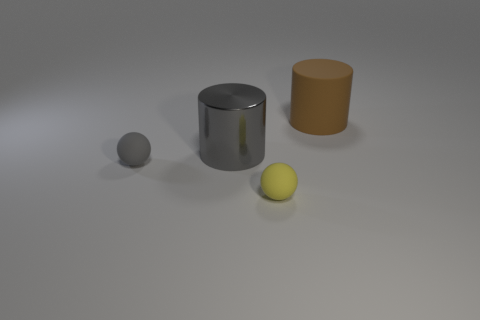What is the color of the other big shiny thing that is the same shape as the big brown thing?
Offer a terse response. Gray. What size is the other object that is the same shape as the tiny yellow rubber object?
Give a very brief answer. Small. What number of gray cylinders are the same material as the brown cylinder?
Offer a terse response. 0. There is a metallic cylinder; does it have the same color as the matte ball that is left of the large gray cylinder?
Your response must be concise. Yes. Are there more gray things than brown things?
Your answer should be compact. Yes. The large shiny thing has what color?
Ensure brevity in your answer.  Gray. Do the large cylinder that is in front of the brown rubber thing and the big rubber cylinder have the same color?
Your response must be concise. No. What is the material of the tiny ball that is the same color as the big metal cylinder?
Make the answer very short. Rubber. What number of metal things have the same color as the shiny cylinder?
Offer a very short reply. 0. There is a tiny object left of the metallic cylinder; is it the same shape as the big brown thing?
Your response must be concise. No. 